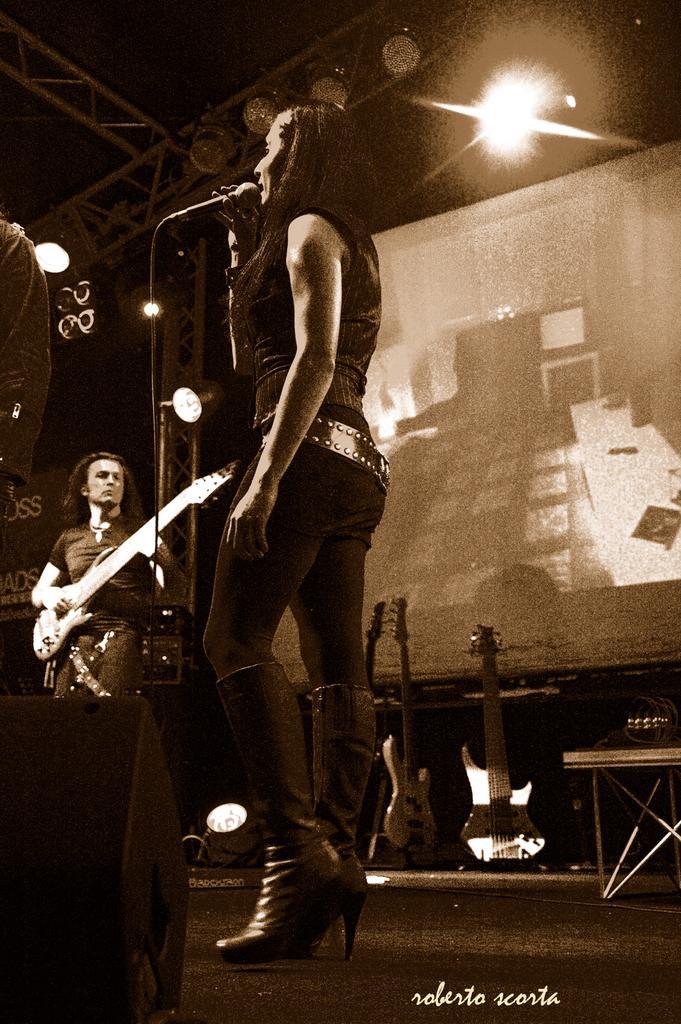Can you describe this image briefly? In this image there are group of persons who are playing musical instruments at the middle of the image there is a person wearing black color dress holding microphone in her hand. 